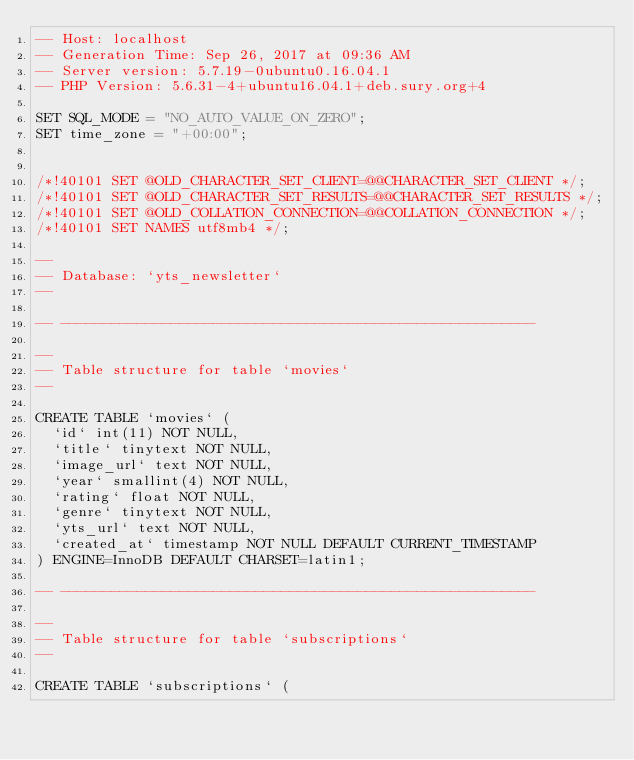Convert code to text. <code><loc_0><loc_0><loc_500><loc_500><_SQL_>-- Host: localhost
-- Generation Time: Sep 26, 2017 at 09:36 AM
-- Server version: 5.7.19-0ubuntu0.16.04.1
-- PHP Version: 5.6.31-4+ubuntu16.04.1+deb.sury.org+4

SET SQL_MODE = "NO_AUTO_VALUE_ON_ZERO";
SET time_zone = "+00:00";


/*!40101 SET @OLD_CHARACTER_SET_CLIENT=@@CHARACTER_SET_CLIENT */;
/*!40101 SET @OLD_CHARACTER_SET_RESULTS=@@CHARACTER_SET_RESULTS */;
/*!40101 SET @OLD_COLLATION_CONNECTION=@@COLLATION_CONNECTION */;
/*!40101 SET NAMES utf8mb4 */;

--
-- Database: `yts_newsletter`
--

-- --------------------------------------------------------

--
-- Table structure for table `movies`
--

CREATE TABLE `movies` (
  `id` int(11) NOT NULL,
  `title` tinytext NOT NULL,
  `image_url` text NOT NULL,
  `year` smallint(4) NOT NULL,
  `rating` float NOT NULL,
  `genre` tinytext NOT NULL,
  `yts_url` text NOT NULL,
  `created_at` timestamp NOT NULL DEFAULT CURRENT_TIMESTAMP
) ENGINE=InnoDB DEFAULT CHARSET=latin1;

-- --------------------------------------------------------

--
-- Table structure for table `subscriptions`
--

CREATE TABLE `subscriptions` (</code> 